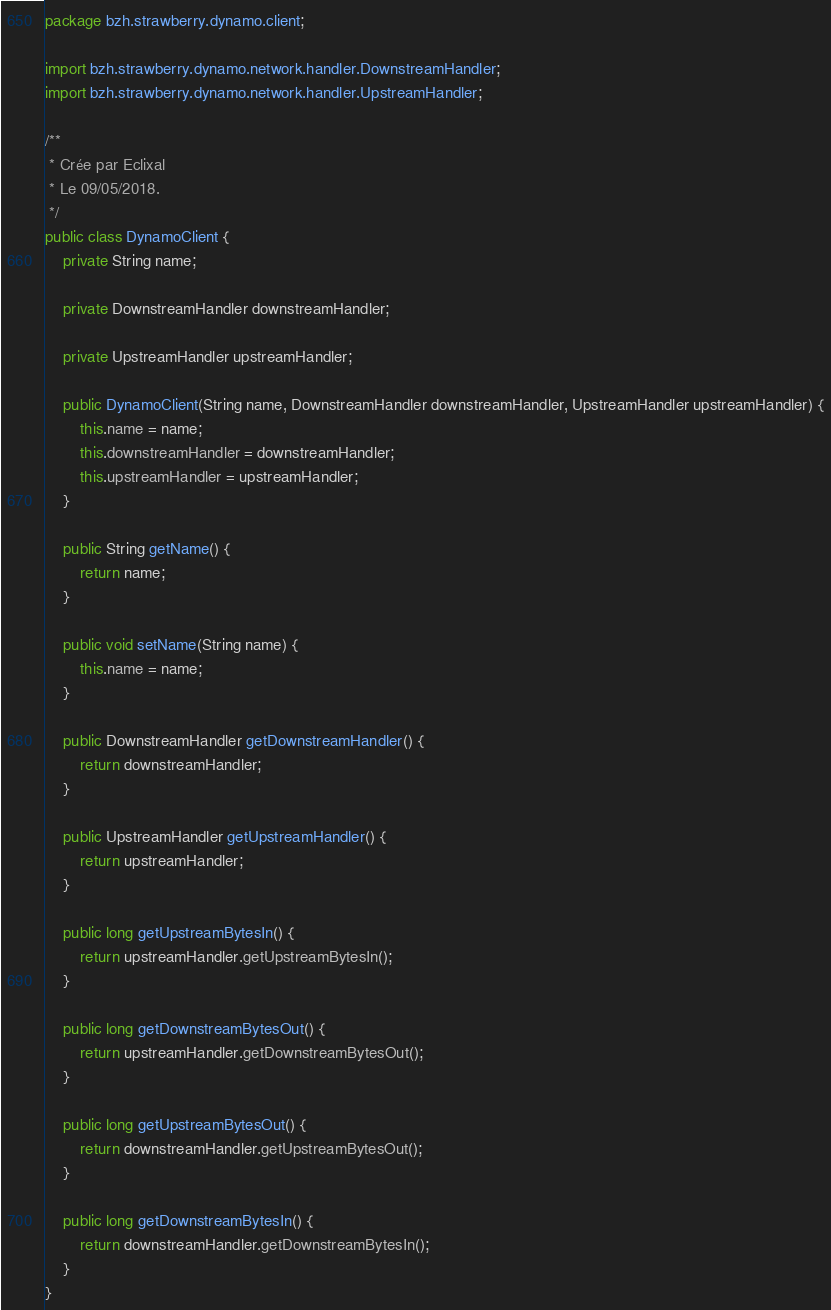<code> <loc_0><loc_0><loc_500><loc_500><_Java_>package bzh.strawberry.dynamo.client;

import bzh.strawberry.dynamo.network.handler.DownstreamHandler;
import bzh.strawberry.dynamo.network.handler.UpstreamHandler;

/**
 * Crée par Eclixal
 * Le 09/05/2018.
 */
public class DynamoClient {
    private String name;

    private DownstreamHandler downstreamHandler;

    private UpstreamHandler upstreamHandler;

    public DynamoClient(String name, DownstreamHandler downstreamHandler, UpstreamHandler upstreamHandler) {
        this.name = name;
        this.downstreamHandler = downstreamHandler;
        this.upstreamHandler = upstreamHandler;
    }

    public String getName() {
        return name;
    }

    public void setName(String name) {
        this.name = name;
    }

    public DownstreamHandler getDownstreamHandler() {
        return downstreamHandler;
    }

    public UpstreamHandler getUpstreamHandler() {
        return upstreamHandler;
    }

    public long getUpstreamBytesIn() {
        return upstreamHandler.getUpstreamBytesIn();
    }

    public long getDownstreamBytesOut() {
        return upstreamHandler.getDownstreamBytesOut();
    }

    public long getUpstreamBytesOut() {
        return downstreamHandler.getUpstreamBytesOut();
    }

    public long getDownstreamBytesIn() {
        return downstreamHandler.getDownstreamBytesIn();
    }
}</code> 